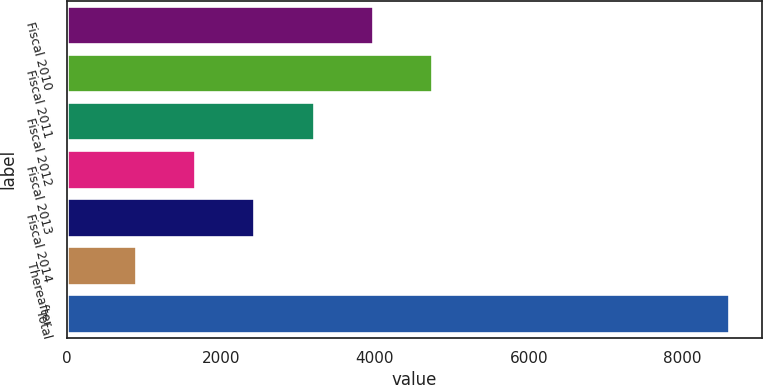Convert chart to OTSL. <chart><loc_0><loc_0><loc_500><loc_500><bar_chart><fcel>Fiscal 2010<fcel>Fiscal 2011<fcel>Fiscal 2012<fcel>Fiscal 2013<fcel>Fiscal 2014<fcel>Thereafter<fcel>Total<nl><fcel>3975<fcel>4745.5<fcel>3204.5<fcel>1663.5<fcel>2434<fcel>893<fcel>8598<nl></chart> 